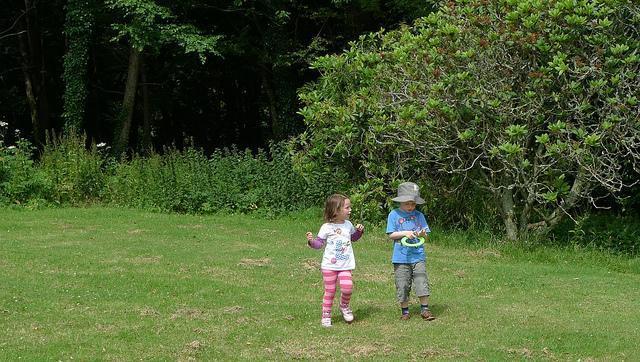How many children are playing?
Give a very brief answer. 2. How many pairs of shoes are in the image?
Give a very brief answer. 2. How many people are in the picture?
Give a very brief answer. 2. How many white birds are there?
Give a very brief answer. 0. 